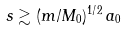<formula> <loc_0><loc_0><loc_500><loc_500>s \gtrsim ( m / M _ { 0 } ) ^ { 1 / 2 } \, a _ { 0 }</formula> 